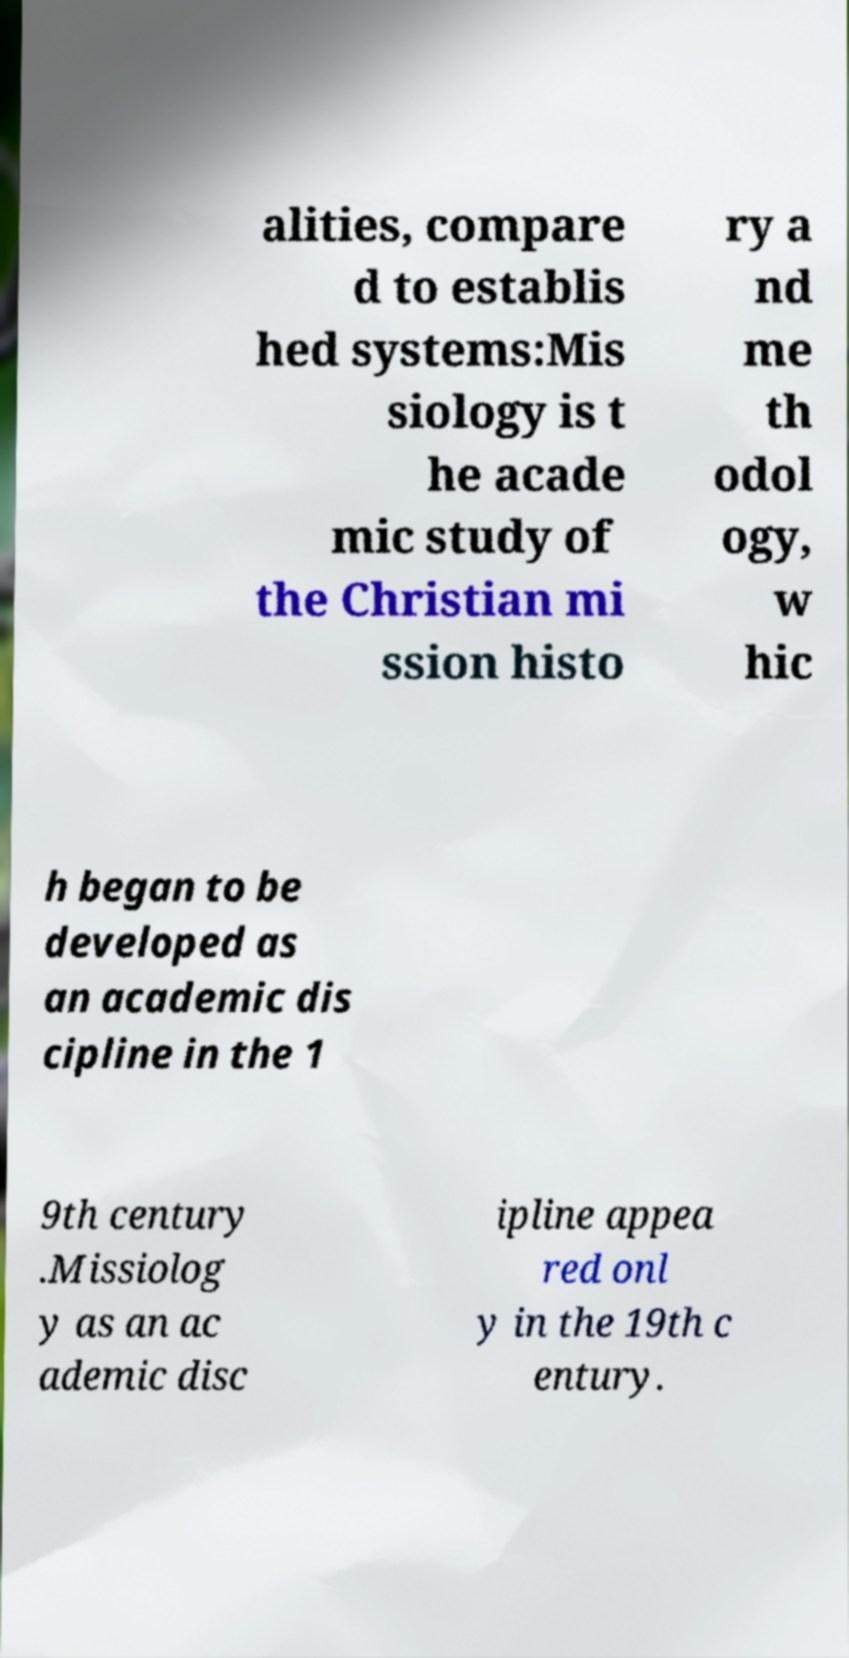I need the written content from this picture converted into text. Can you do that? alities, compare d to establis hed systems:Mis siology is t he acade mic study of the Christian mi ssion histo ry a nd me th odol ogy, w hic h began to be developed as an academic dis cipline in the 1 9th century .Missiolog y as an ac ademic disc ipline appea red onl y in the 19th c entury. 